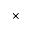Convert formula to latex. <formula><loc_0><loc_0><loc_500><loc_500>\times</formula> 